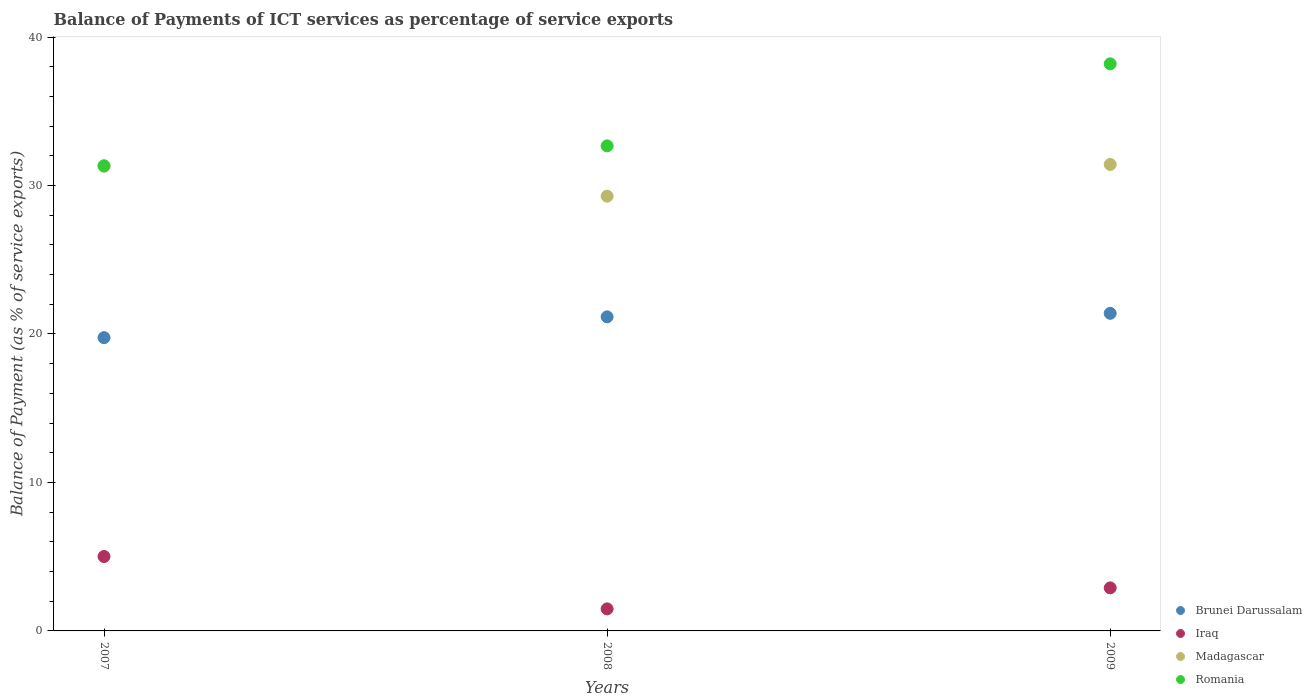Is the number of dotlines equal to the number of legend labels?
Keep it short and to the point. Yes. What is the balance of payments of ICT services in Madagascar in 2008?
Your answer should be very brief. 29.28. Across all years, what is the maximum balance of payments of ICT services in Iraq?
Your answer should be compact. 5.01. Across all years, what is the minimum balance of payments of ICT services in Brunei Darussalam?
Provide a short and direct response. 19.75. What is the total balance of payments of ICT services in Romania in the graph?
Give a very brief answer. 102.2. What is the difference between the balance of payments of ICT services in Iraq in 2008 and that in 2009?
Provide a succinct answer. -1.42. What is the difference between the balance of payments of ICT services in Brunei Darussalam in 2009 and the balance of payments of ICT services in Madagascar in 2007?
Provide a short and direct response. -9.91. What is the average balance of payments of ICT services in Madagascar per year?
Give a very brief answer. 30.67. In the year 2007, what is the difference between the balance of payments of ICT services in Madagascar and balance of payments of ICT services in Brunei Darussalam?
Your answer should be very brief. 11.55. In how many years, is the balance of payments of ICT services in Brunei Darussalam greater than 30 %?
Your answer should be very brief. 0. What is the ratio of the balance of payments of ICT services in Iraq in 2007 to that in 2009?
Provide a short and direct response. 1.73. Is the balance of payments of ICT services in Brunei Darussalam in 2007 less than that in 2009?
Your answer should be compact. Yes. What is the difference between the highest and the second highest balance of payments of ICT services in Romania?
Make the answer very short. 5.53. What is the difference between the highest and the lowest balance of payments of ICT services in Romania?
Make the answer very short. 6.87. Is the balance of payments of ICT services in Romania strictly greater than the balance of payments of ICT services in Iraq over the years?
Ensure brevity in your answer.  Yes. Is the balance of payments of ICT services in Romania strictly less than the balance of payments of ICT services in Iraq over the years?
Your answer should be compact. No. How many dotlines are there?
Offer a very short reply. 4. How many years are there in the graph?
Your answer should be compact. 3. What is the difference between two consecutive major ticks on the Y-axis?
Your answer should be compact. 10. Are the values on the major ticks of Y-axis written in scientific E-notation?
Your response must be concise. No. Does the graph contain grids?
Keep it short and to the point. No. How many legend labels are there?
Make the answer very short. 4. How are the legend labels stacked?
Your answer should be compact. Vertical. What is the title of the graph?
Offer a very short reply. Balance of Payments of ICT services as percentage of service exports. Does "Isle of Man" appear as one of the legend labels in the graph?
Make the answer very short. No. What is the label or title of the Y-axis?
Your response must be concise. Balance of Payment (as % of service exports). What is the Balance of Payment (as % of service exports) of Brunei Darussalam in 2007?
Offer a very short reply. 19.75. What is the Balance of Payment (as % of service exports) of Iraq in 2007?
Give a very brief answer. 5.01. What is the Balance of Payment (as % of service exports) in Madagascar in 2007?
Provide a short and direct response. 31.3. What is the Balance of Payment (as % of service exports) of Romania in 2007?
Offer a terse response. 31.33. What is the Balance of Payment (as % of service exports) in Brunei Darussalam in 2008?
Make the answer very short. 21.15. What is the Balance of Payment (as % of service exports) of Iraq in 2008?
Your response must be concise. 1.48. What is the Balance of Payment (as % of service exports) in Madagascar in 2008?
Your answer should be compact. 29.28. What is the Balance of Payment (as % of service exports) of Romania in 2008?
Make the answer very short. 32.67. What is the Balance of Payment (as % of service exports) in Brunei Darussalam in 2009?
Offer a very short reply. 21.39. What is the Balance of Payment (as % of service exports) in Iraq in 2009?
Ensure brevity in your answer.  2.9. What is the Balance of Payment (as % of service exports) in Madagascar in 2009?
Provide a succinct answer. 31.42. What is the Balance of Payment (as % of service exports) in Romania in 2009?
Provide a succinct answer. 38.2. Across all years, what is the maximum Balance of Payment (as % of service exports) of Brunei Darussalam?
Ensure brevity in your answer.  21.39. Across all years, what is the maximum Balance of Payment (as % of service exports) of Iraq?
Make the answer very short. 5.01. Across all years, what is the maximum Balance of Payment (as % of service exports) in Madagascar?
Provide a succinct answer. 31.42. Across all years, what is the maximum Balance of Payment (as % of service exports) of Romania?
Your response must be concise. 38.2. Across all years, what is the minimum Balance of Payment (as % of service exports) in Brunei Darussalam?
Your response must be concise. 19.75. Across all years, what is the minimum Balance of Payment (as % of service exports) of Iraq?
Your answer should be very brief. 1.48. Across all years, what is the minimum Balance of Payment (as % of service exports) of Madagascar?
Offer a very short reply. 29.28. Across all years, what is the minimum Balance of Payment (as % of service exports) of Romania?
Your answer should be very brief. 31.33. What is the total Balance of Payment (as % of service exports) in Brunei Darussalam in the graph?
Provide a succinct answer. 62.3. What is the total Balance of Payment (as % of service exports) of Iraq in the graph?
Keep it short and to the point. 9.4. What is the total Balance of Payment (as % of service exports) in Madagascar in the graph?
Offer a very short reply. 92.01. What is the total Balance of Payment (as % of service exports) in Romania in the graph?
Your answer should be compact. 102.2. What is the difference between the Balance of Payment (as % of service exports) of Brunei Darussalam in 2007 and that in 2008?
Your answer should be compact. -1.4. What is the difference between the Balance of Payment (as % of service exports) of Iraq in 2007 and that in 2008?
Keep it short and to the point. 3.53. What is the difference between the Balance of Payment (as % of service exports) in Madagascar in 2007 and that in 2008?
Your response must be concise. 2.02. What is the difference between the Balance of Payment (as % of service exports) of Romania in 2007 and that in 2008?
Keep it short and to the point. -1.34. What is the difference between the Balance of Payment (as % of service exports) in Brunei Darussalam in 2007 and that in 2009?
Your answer should be very brief. -1.64. What is the difference between the Balance of Payment (as % of service exports) in Iraq in 2007 and that in 2009?
Keep it short and to the point. 2.11. What is the difference between the Balance of Payment (as % of service exports) of Madagascar in 2007 and that in 2009?
Your answer should be very brief. -0.12. What is the difference between the Balance of Payment (as % of service exports) of Romania in 2007 and that in 2009?
Offer a terse response. -6.87. What is the difference between the Balance of Payment (as % of service exports) in Brunei Darussalam in 2008 and that in 2009?
Keep it short and to the point. -0.24. What is the difference between the Balance of Payment (as % of service exports) in Iraq in 2008 and that in 2009?
Provide a succinct answer. -1.42. What is the difference between the Balance of Payment (as % of service exports) of Madagascar in 2008 and that in 2009?
Make the answer very short. -2.14. What is the difference between the Balance of Payment (as % of service exports) of Romania in 2008 and that in 2009?
Keep it short and to the point. -5.53. What is the difference between the Balance of Payment (as % of service exports) of Brunei Darussalam in 2007 and the Balance of Payment (as % of service exports) of Iraq in 2008?
Make the answer very short. 18.27. What is the difference between the Balance of Payment (as % of service exports) of Brunei Darussalam in 2007 and the Balance of Payment (as % of service exports) of Madagascar in 2008?
Your answer should be very brief. -9.53. What is the difference between the Balance of Payment (as % of service exports) of Brunei Darussalam in 2007 and the Balance of Payment (as % of service exports) of Romania in 2008?
Your answer should be compact. -12.92. What is the difference between the Balance of Payment (as % of service exports) in Iraq in 2007 and the Balance of Payment (as % of service exports) in Madagascar in 2008?
Ensure brevity in your answer.  -24.27. What is the difference between the Balance of Payment (as % of service exports) in Iraq in 2007 and the Balance of Payment (as % of service exports) in Romania in 2008?
Provide a succinct answer. -27.66. What is the difference between the Balance of Payment (as % of service exports) in Madagascar in 2007 and the Balance of Payment (as % of service exports) in Romania in 2008?
Offer a terse response. -1.37. What is the difference between the Balance of Payment (as % of service exports) in Brunei Darussalam in 2007 and the Balance of Payment (as % of service exports) in Iraq in 2009?
Your answer should be very brief. 16.85. What is the difference between the Balance of Payment (as % of service exports) of Brunei Darussalam in 2007 and the Balance of Payment (as % of service exports) of Madagascar in 2009?
Offer a terse response. -11.67. What is the difference between the Balance of Payment (as % of service exports) in Brunei Darussalam in 2007 and the Balance of Payment (as % of service exports) in Romania in 2009?
Provide a short and direct response. -18.44. What is the difference between the Balance of Payment (as % of service exports) in Iraq in 2007 and the Balance of Payment (as % of service exports) in Madagascar in 2009?
Your answer should be compact. -26.41. What is the difference between the Balance of Payment (as % of service exports) in Iraq in 2007 and the Balance of Payment (as % of service exports) in Romania in 2009?
Offer a very short reply. -33.18. What is the difference between the Balance of Payment (as % of service exports) of Madagascar in 2007 and the Balance of Payment (as % of service exports) of Romania in 2009?
Your answer should be very brief. -6.9. What is the difference between the Balance of Payment (as % of service exports) in Brunei Darussalam in 2008 and the Balance of Payment (as % of service exports) in Iraq in 2009?
Make the answer very short. 18.25. What is the difference between the Balance of Payment (as % of service exports) of Brunei Darussalam in 2008 and the Balance of Payment (as % of service exports) of Madagascar in 2009?
Your answer should be compact. -10.27. What is the difference between the Balance of Payment (as % of service exports) of Brunei Darussalam in 2008 and the Balance of Payment (as % of service exports) of Romania in 2009?
Your answer should be compact. -17.04. What is the difference between the Balance of Payment (as % of service exports) in Iraq in 2008 and the Balance of Payment (as % of service exports) in Madagascar in 2009?
Offer a terse response. -29.94. What is the difference between the Balance of Payment (as % of service exports) of Iraq in 2008 and the Balance of Payment (as % of service exports) of Romania in 2009?
Ensure brevity in your answer.  -36.71. What is the difference between the Balance of Payment (as % of service exports) of Madagascar in 2008 and the Balance of Payment (as % of service exports) of Romania in 2009?
Keep it short and to the point. -8.91. What is the average Balance of Payment (as % of service exports) of Brunei Darussalam per year?
Offer a terse response. 20.77. What is the average Balance of Payment (as % of service exports) of Iraq per year?
Offer a very short reply. 3.13. What is the average Balance of Payment (as % of service exports) of Madagascar per year?
Make the answer very short. 30.67. What is the average Balance of Payment (as % of service exports) in Romania per year?
Provide a short and direct response. 34.07. In the year 2007, what is the difference between the Balance of Payment (as % of service exports) in Brunei Darussalam and Balance of Payment (as % of service exports) in Iraq?
Your response must be concise. 14.74. In the year 2007, what is the difference between the Balance of Payment (as % of service exports) of Brunei Darussalam and Balance of Payment (as % of service exports) of Madagascar?
Ensure brevity in your answer.  -11.55. In the year 2007, what is the difference between the Balance of Payment (as % of service exports) of Brunei Darussalam and Balance of Payment (as % of service exports) of Romania?
Provide a short and direct response. -11.58. In the year 2007, what is the difference between the Balance of Payment (as % of service exports) of Iraq and Balance of Payment (as % of service exports) of Madagascar?
Make the answer very short. -26.29. In the year 2007, what is the difference between the Balance of Payment (as % of service exports) in Iraq and Balance of Payment (as % of service exports) in Romania?
Your response must be concise. -26.32. In the year 2007, what is the difference between the Balance of Payment (as % of service exports) in Madagascar and Balance of Payment (as % of service exports) in Romania?
Provide a succinct answer. -0.03. In the year 2008, what is the difference between the Balance of Payment (as % of service exports) in Brunei Darussalam and Balance of Payment (as % of service exports) in Iraq?
Your response must be concise. 19.67. In the year 2008, what is the difference between the Balance of Payment (as % of service exports) in Brunei Darussalam and Balance of Payment (as % of service exports) in Madagascar?
Provide a short and direct response. -8.13. In the year 2008, what is the difference between the Balance of Payment (as % of service exports) in Brunei Darussalam and Balance of Payment (as % of service exports) in Romania?
Offer a very short reply. -11.52. In the year 2008, what is the difference between the Balance of Payment (as % of service exports) in Iraq and Balance of Payment (as % of service exports) in Madagascar?
Your answer should be compact. -27.8. In the year 2008, what is the difference between the Balance of Payment (as % of service exports) in Iraq and Balance of Payment (as % of service exports) in Romania?
Make the answer very short. -31.19. In the year 2008, what is the difference between the Balance of Payment (as % of service exports) of Madagascar and Balance of Payment (as % of service exports) of Romania?
Make the answer very short. -3.39. In the year 2009, what is the difference between the Balance of Payment (as % of service exports) in Brunei Darussalam and Balance of Payment (as % of service exports) in Iraq?
Make the answer very short. 18.49. In the year 2009, what is the difference between the Balance of Payment (as % of service exports) of Brunei Darussalam and Balance of Payment (as % of service exports) of Madagascar?
Give a very brief answer. -10.03. In the year 2009, what is the difference between the Balance of Payment (as % of service exports) of Brunei Darussalam and Balance of Payment (as % of service exports) of Romania?
Provide a succinct answer. -16.81. In the year 2009, what is the difference between the Balance of Payment (as % of service exports) in Iraq and Balance of Payment (as % of service exports) in Madagascar?
Give a very brief answer. -28.52. In the year 2009, what is the difference between the Balance of Payment (as % of service exports) of Iraq and Balance of Payment (as % of service exports) of Romania?
Provide a succinct answer. -35.3. In the year 2009, what is the difference between the Balance of Payment (as % of service exports) of Madagascar and Balance of Payment (as % of service exports) of Romania?
Your response must be concise. -6.78. What is the ratio of the Balance of Payment (as % of service exports) in Brunei Darussalam in 2007 to that in 2008?
Give a very brief answer. 0.93. What is the ratio of the Balance of Payment (as % of service exports) of Iraq in 2007 to that in 2008?
Provide a short and direct response. 3.38. What is the ratio of the Balance of Payment (as % of service exports) of Madagascar in 2007 to that in 2008?
Give a very brief answer. 1.07. What is the ratio of the Balance of Payment (as % of service exports) of Romania in 2007 to that in 2008?
Keep it short and to the point. 0.96. What is the ratio of the Balance of Payment (as % of service exports) of Brunei Darussalam in 2007 to that in 2009?
Provide a short and direct response. 0.92. What is the ratio of the Balance of Payment (as % of service exports) in Iraq in 2007 to that in 2009?
Your response must be concise. 1.73. What is the ratio of the Balance of Payment (as % of service exports) in Romania in 2007 to that in 2009?
Provide a succinct answer. 0.82. What is the ratio of the Balance of Payment (as % of service exports) of Brunei Darussalam in 2008 to that in 2009?
Make the answer very short. 0.99. What is the ratio of the Balance of Payment (as % of service exports) of Iraq in 2008 to that in 2009?
Your answer should be compact. 0.51. What is the ratio of the Balance of Payment (as % of service exports) in Madagascar in 2008 to that in 2009?
Offer a terse response. 0.93. What is the ratio of the Balance of Payment (as % of service exports) in Romania in 2008 to that in 2009?
Your answer should be very brief. 0.86. What is the difference between the highest and the second highest Balance of Payment (as % of service exports) of Brunei Darussalam?
Provide a short and direct response. 0.24. What is the difference between the highest and the second highest Balance of Payment (as % of service exports) in Iraq?
Make the answer very short. 2.11. What is the difference between the highest and the second highest Balance of Payment (as % of service exports) of Madagascar?
Your answer should be compact. 0.12. What is the difference between the highest and the second highest Balance of Payment (as % of service exports) in Romania?
Make the answer very short. 5.53. What is the difference between the highest and the lowest Balance of Payment (as % of service exports) in Brunei Darussalam?
Provide a short and direct response. 1.64. What is the difference between the highest and the lowest Balance of Payment (as % of service exports) of Iraq?
Your response must be concise. 3.53. What is the difference between the highest and the lowest Balance of Payment (as % of service exports) of Madagascar?
Your response must be concise. 2.14. What is the difference between the highest and the lowest Balance of Payment (as % of service exports) in Romania?
Offer a very short reply. 6.87. 